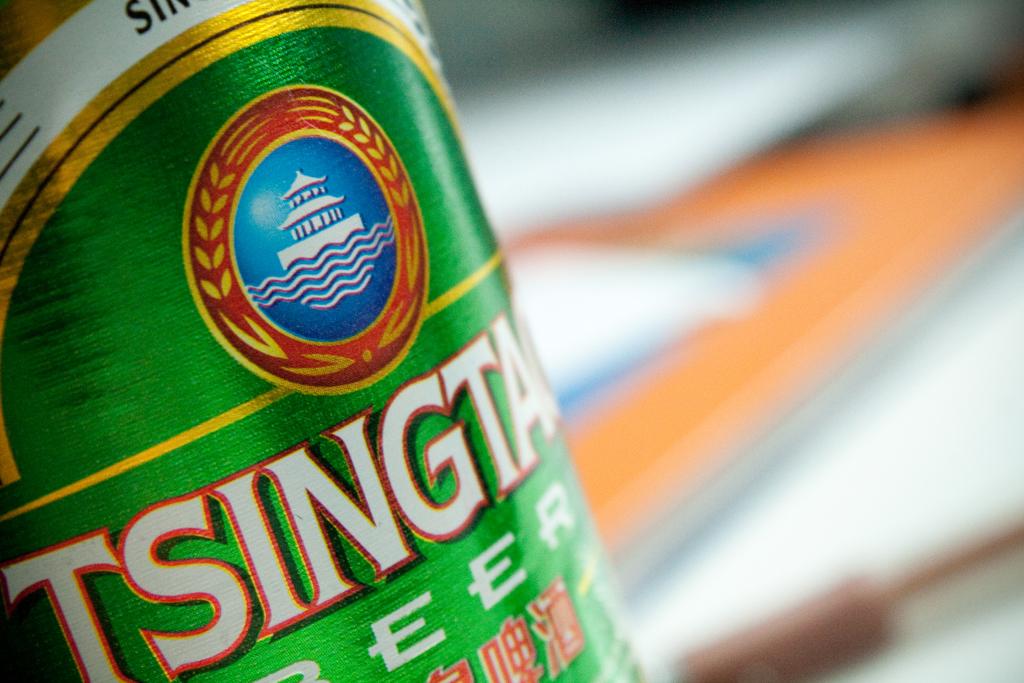What brand of drink is it?
Make the answer very short. Tsingta. What kind of drink is this?
Your answer should be compact. Beer. 